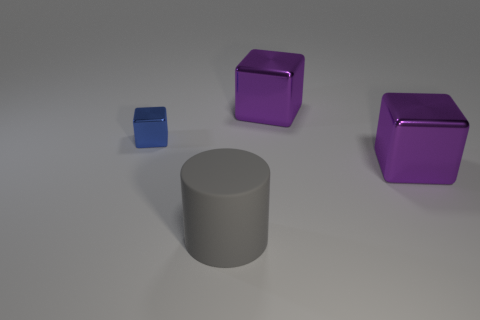Subtract all cyan cylinders. Subtract all gray spheres. How many cylinders are left? 1 Add 1 tiny gray metallic objects. How many objects exist? 5 Subtract all cubes. How many objects are left? 1 Add 3 large purple things. How many large purple things are left? 5 Add 3 blue things. How many blue things exist? 4 Subtract 0 brown blocks. How many objects are left? 4 Subtract all small blue metallic things. Subtract all small blue matte blocks. How many objects are left? 3 